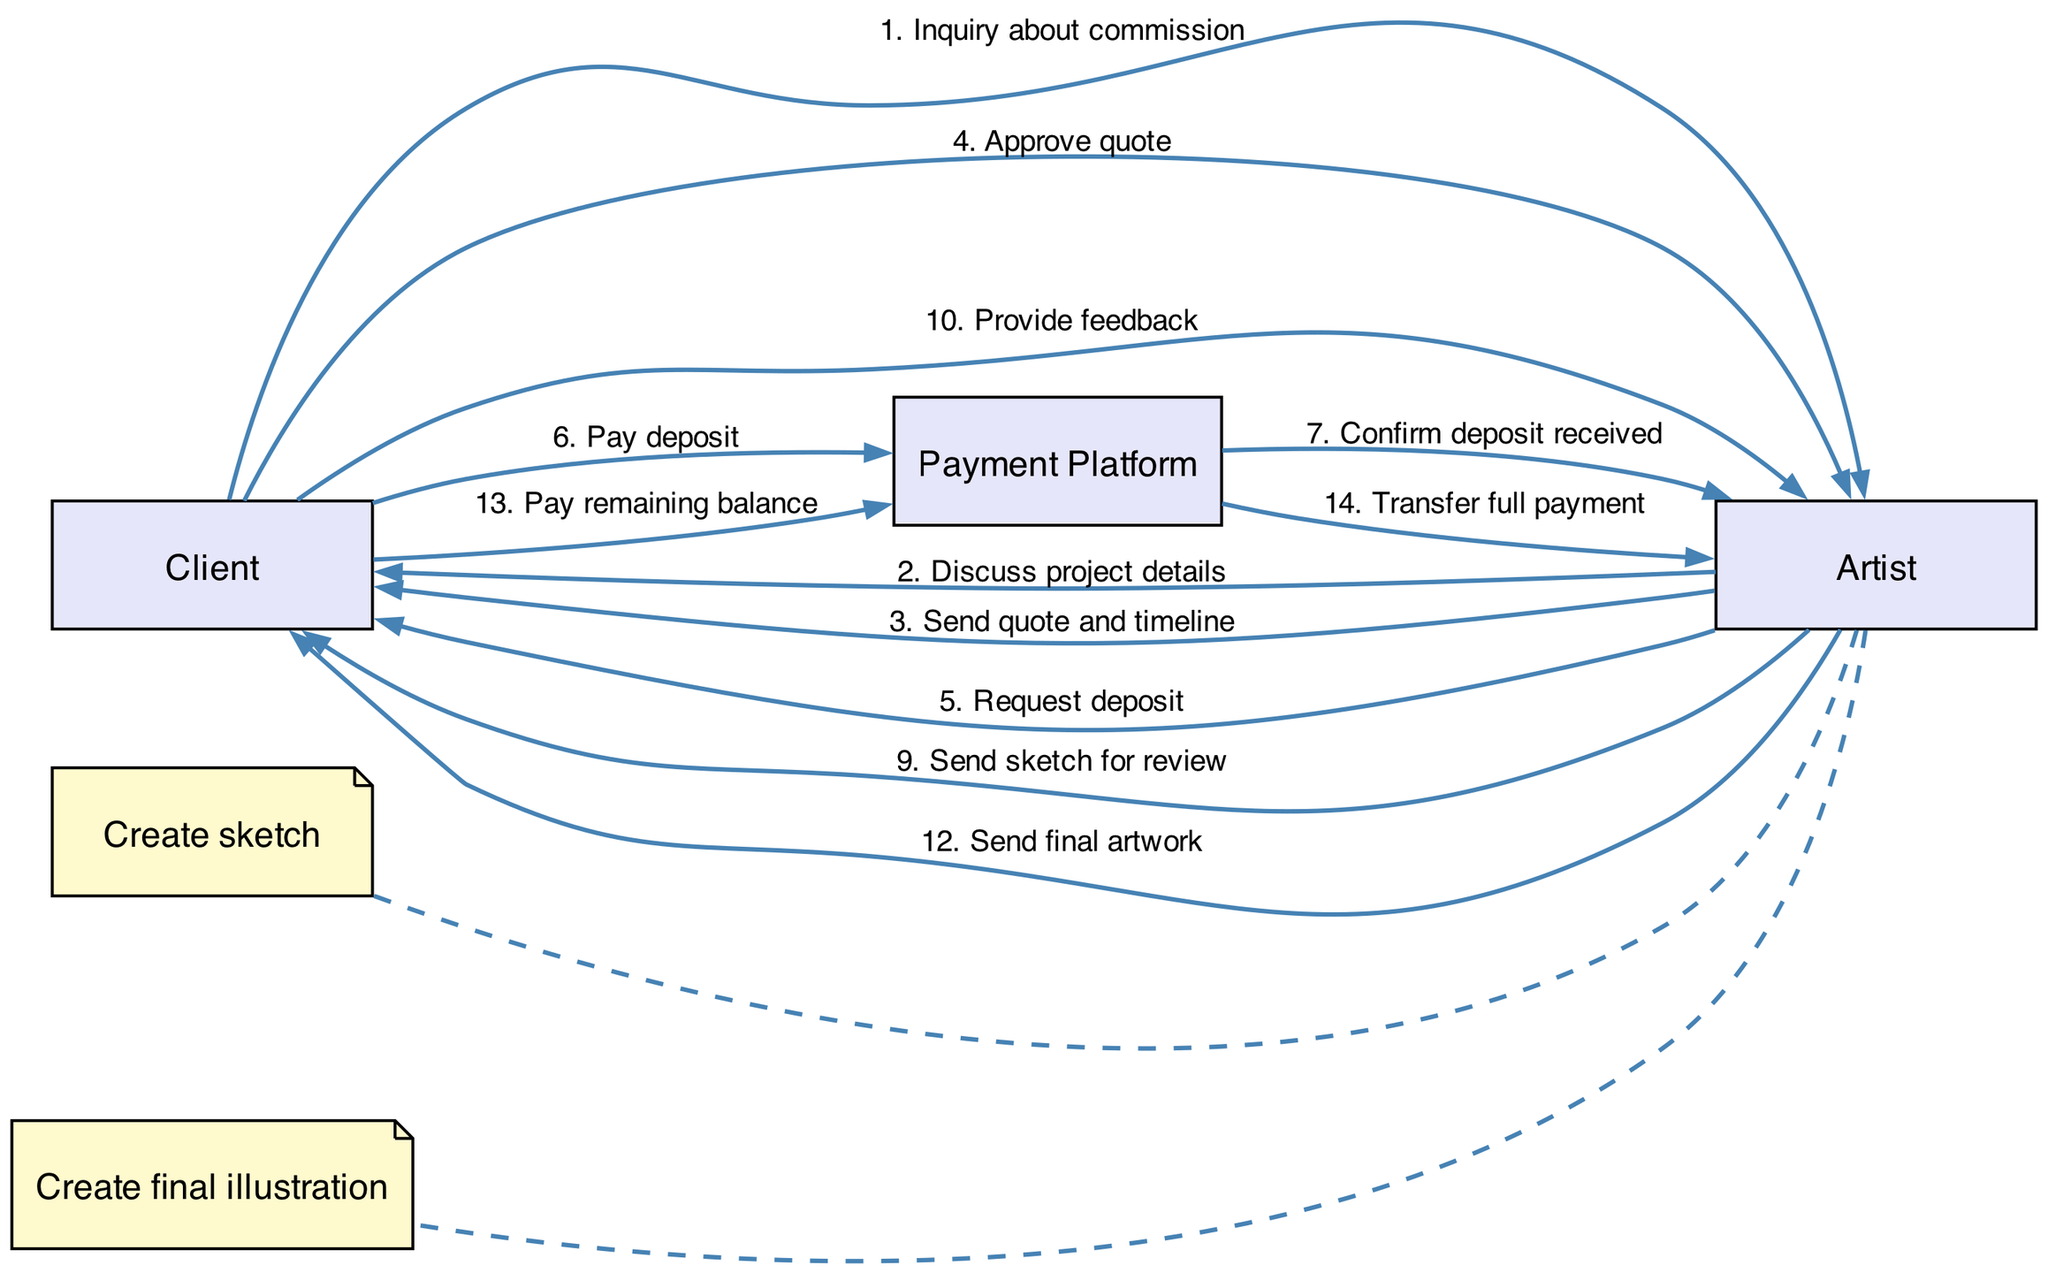What is the first message in the diagram? The first message flows from "Client" to "Artist" and is titled "Inquiry about commission". Therefore, it indicates the initiation of the communication process.
Answer: Inquiry about commission How many actors are present in the diagram? The diagram includes three actors: "Client," "Artist," and "Payment Platform." This count represents all entities involved in the art commission lifecycle.
Answer: 3 What does the Artist request after sending the quote? After sending the quote, the Artist requests a "deposit". This step is crucial for beginning the commission process before work can commence.
Answer: Request deposit Which actor confirms the deposit received? The "Payment Platform" is the actor that confirms the deposit has been received. This indicates the financial transaction stage in the overall process.
Answer: Payment Platform What is the final message exchanged in the diagram? The final message is from the "Payment Platform" to the "Artist," labeled "Transfer full payment." This signifies the completion of the financial obligations linked to the commission.
Answer: Transfer full payment Which step involves client feedback to the artist? The step that involves feedback takes place when "Client" sends "Provide feedback" to "Artist" upon reviewing the sketch. This is a critical phase for ensuring the artwork aligns with client expectations.
Answer: Provide feedback How many messages are sent from the Artist to the Client? The Artist sends four messages to the Client throughout the diagram: discussing project details, sending a quote and timeline, requesting a deposit, and sending the final artwork. This indicates interactive communication between the two parties.
Answer: 4 What type of diagram is this? This is a sequence diagram, as it illustrates the interaction between actors over time, highlighting the flow of messages in a specific order related to the art commission process.
Answer: Sequence diagram Which actor handles the payment transactions? The "Payment Platform" manages all payment-related transactions in the process, ensuring financial exchanges are smoothly facilitated between the Client and the Artist.
Answer: Payment Platform 